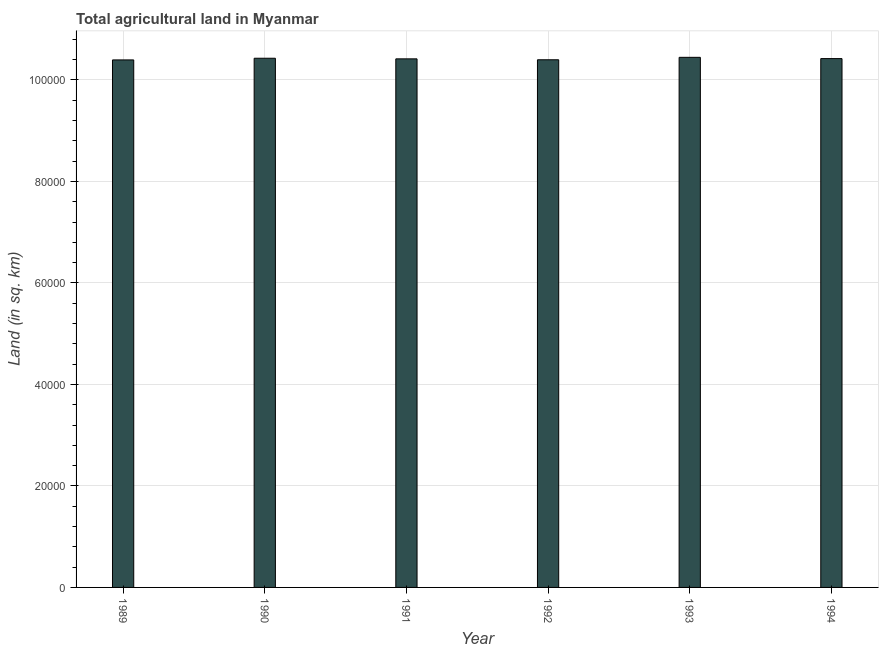What is the title of the graph?
Your answer should be very brief. Total agricultural land in Myanmar. What is the label or title of the X-axis?
Make the answer very short. Year. What is the label or title of the Y-axis?
Your answer should be very brief. Land (in sq. km). What is the agricultural land in 1990?
Your answer should be compact. 1.04e+05. Across all years, what is the maximum agricultural land?
Keep it short and to the point. 1.04e+05. Across all years, what is the minimum agricultural land?
Ensure brevity in your answer.  1.04e+05. What is the sum of the agricultural land?
Keep it short and to the point. 6.25e+05. What is the average agricultural land per year?
Your answer should be very brief. 1.04e+05. What is the median agricultural land?
Offer a terse response. 1.04e+05. Do a majority of the years between 1994 and 1989 (inclusive) have agricultural land greater than 84000 sq. km?
Make the answer very short. Yes. What is the ratio of the agricultural land in 1989 to that in 1990?
Offer a terse response. 1. Is the difference between the agricultural land in 1990 and 1993 greater than the difference between any two years?
Your response must be concise. No. What is the difference between the highest and the second highest agricultural land?
Provide a succinct answer. 180. Is the sum of the agricultural land in 1991 and 1994 greater than the maximum agricultural land across all years?
Ensure brevity in your answer.  Yes. What is the difference between the highest and the lowest agricultural land?
Give a very brief answer. 510. What is the difference between two consecutive major ticks on the Y-axis?
Provide a succinct answer. 2.00e+04. What is the Land (in sq. km) of 1989?
Give a very brief answer. 1.04e+05. What is the Land (in sq. km) of 1990?
Give a very brief answer. 1.04e+05. What is the Land (in sq. km) in 1991?
Provide a short and direct response. 1.04e+05. What is the Land (in sq. km) of 1992?
Your answer should be very brief. 1.04e+05. What is the Land (in sq. km) in 1993?
Ensure brevity in your answer.  1.04e+05. What is the Land (in sq. km) in 1994?
Give a very brief answer. 1.04e+05. What is the difference between the Land (in sq. km) in 1989 and 1990?
Offer a terse response. -330. What is the difference between the Land (in sq. km) in 1989 and 1991?
Offer a very short reply. -210. What is the difference between the Land (in sq. km) in 1989 and 1992?
Provide a short and direct response. -30. What is the difference between the Land (in sq. km) in 1989 and 1993?
Make the answer very short. -510. What is the difference between the Land (in sq. km) in 1989 and 1994?
Your response must be concise. -260. What is the difference between the Land (in sq. km) in 1990 and 1991?
Offer a terse response. 120. What is the difference between the Land (in sq. km) in 1990 and 1992?
Your response must be concise. 300. What is the difference between the Land (in sq. km) in 1990 and 1993?
Provide a succinct answer. -180. What is the difference between the Land (in sq. km) in 1990 and 1994?
Your answer should be compact. 70. What is the difference between the Land (in sq. km) in 1991 and 1992?
Offer a terse response. 180. What is the difference between the Land (in sq. km) in 1991 and 1993?
Provide a short and direct response. -300. What is the difference between the Land (in sq. km) in 1991 and 1994?
Ensure brevity in your answer.  -50. What is the difference between the Land (in sq. km) in 1992 and 1993?
Provide a short and direct response. -480. What is the difference between the Land (in sq. km) in 1992 and 1994?
Ensure brevity in your answer.  -230. What is the difference between the Land (in sq. km) in 1993 and 1994?
Make the answer very short. 250. What is the ratio of the Land (in sq. km) in 1989 to that in 1993?
Ensure brevity in your answer.  0.99. What is the ratio of the Land (in sq. km) in 1989 to that in 1994?
Offer a very short reply. 1. What is the ratio of the Land (in sq. km) in 1990 to that in 1991?
Offer a very short reply. 1. What is the ratio of the Land (in sq. km) in 1991 to that in 1994?
Give a very brief answer. 1. What is the ratio of the Land (in sq. km) in 1992 to that in 1993?
Provide a succinct answer. 0.99. What is the ratio of the Land (in sq. km) in 1993 to that in 1994?
Your answer should be compact. 1. 